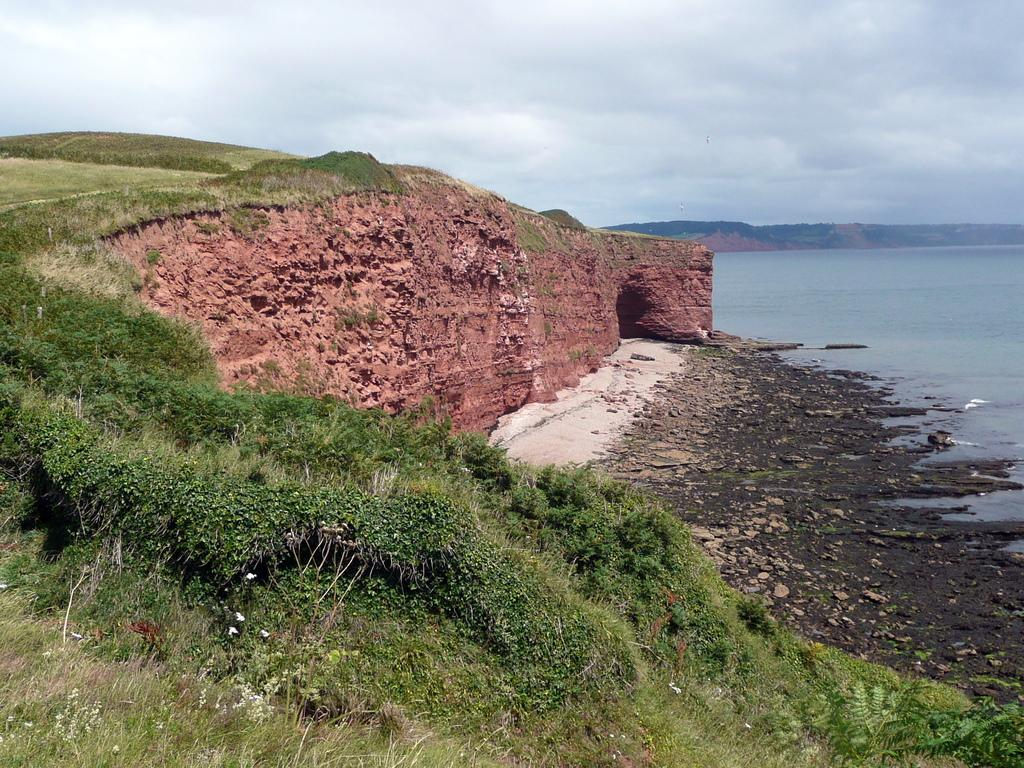What type of landscape is depicted in the image? There is a grassland in the image. What natural feature can be seen in the image? There is a river in the image. What is visible in the background of the image? The sky is visible in the background of the image. How would you describe the weather based on the appearance of the sky? The sky appears to be cloudy. What type of secretary is standing near the river in the image? There is no secretary present in the image; it features a grassland and a river. How does the grassland show respect to the river in the image? The grassland does not show respect to the river in the image; it is a natural landscape feature. 